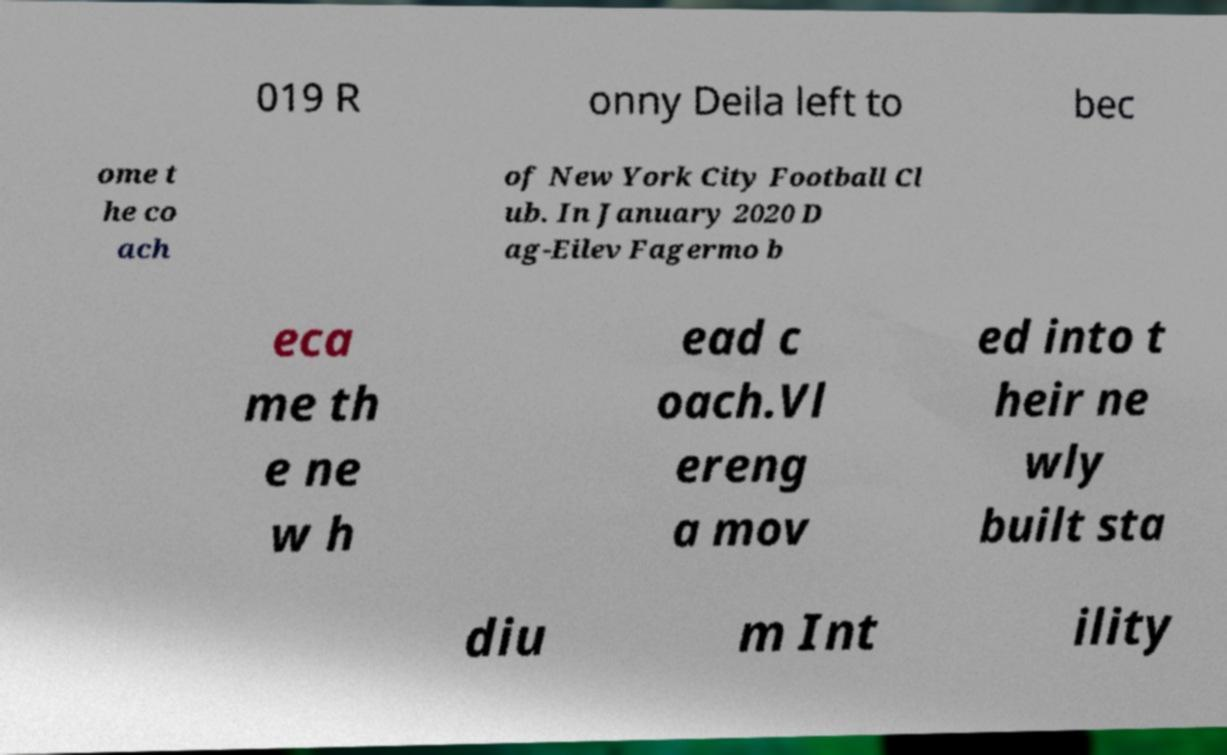There's text embedded in this image that I need extracted. Can you transcribe it verbatim? 019 R onny Deila left to bec ome t he co ach of New York City Football Cl ub. In January 2020 D ag-Eilev Fagermo b eca me th e ne w h ead c oach.Vl ereng a mov ed into t heir ne wly built sta diu m Int ility 